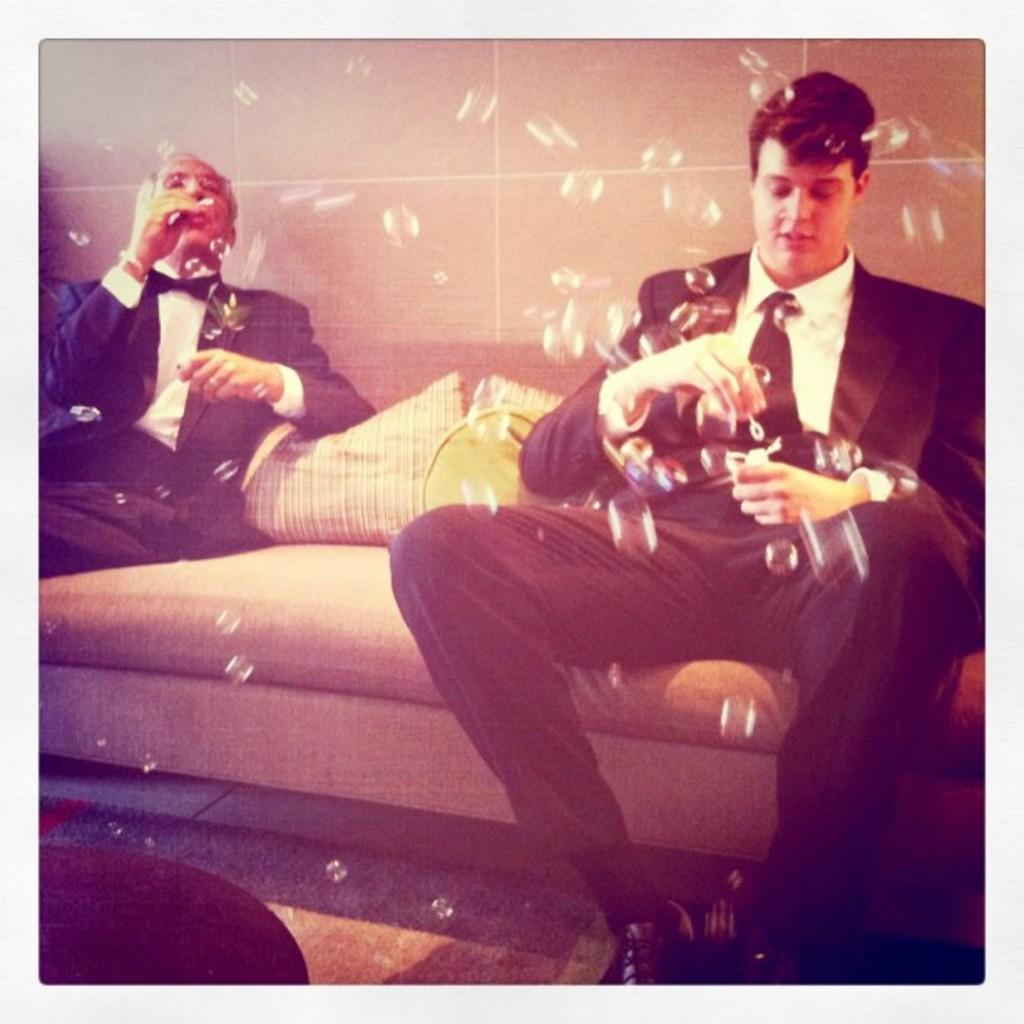How many people are in the image? There are two men in the image. What are the men doing in the image? The men are sitting on a couch. What are the men holding in their hands? The men are holding objects in their hands. What can be seen on the couch besides the men? There are pillows on the couch. What is visible in the background of the image? Air bubbles and a wall are visible in the image. What scene is being depicted in the image? The image does not depict a scene; it is a photograph of two men sitting on a couch. How does the wall push the air bubbles in the image? The wall does not push the air bubbles in the image; the air bubbles are likely a result of the photographic technique or editing. 